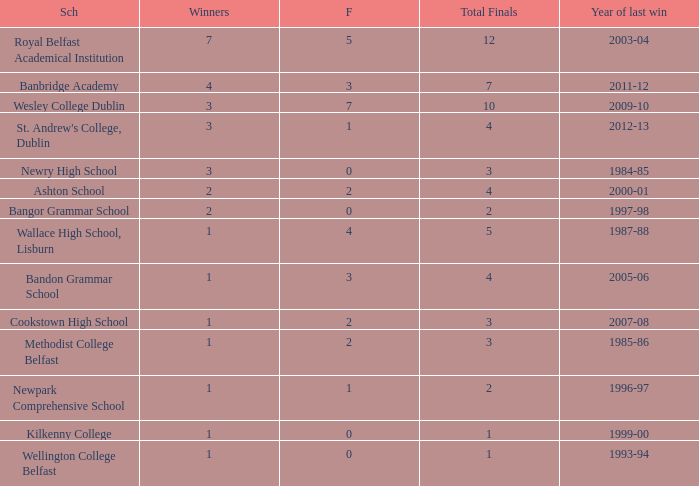What is the name of the school where the year of last win is 1985-86? Methodist College Belfast. 